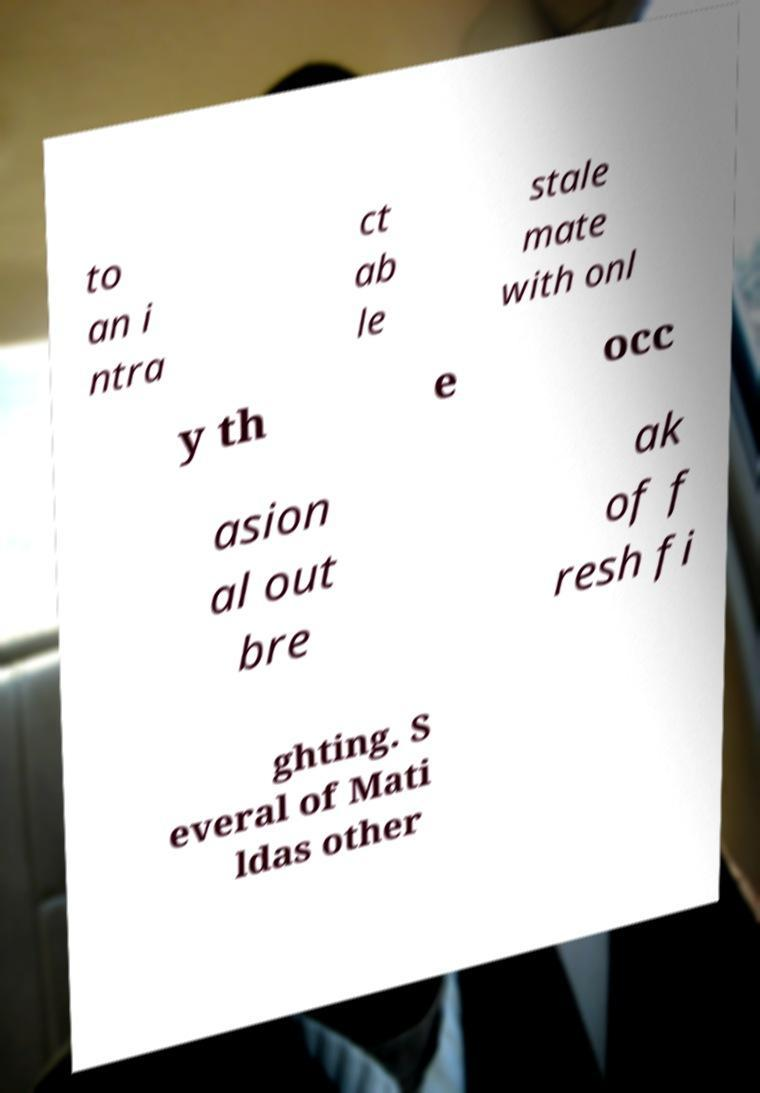For documentation purposes, I need the text within this image transcribed. Could you provide that? to an i ntra ct ab le stale mate with onl y th e occ asion al out bre ak of f resh fi ghting. S everal of Mati ldas other 